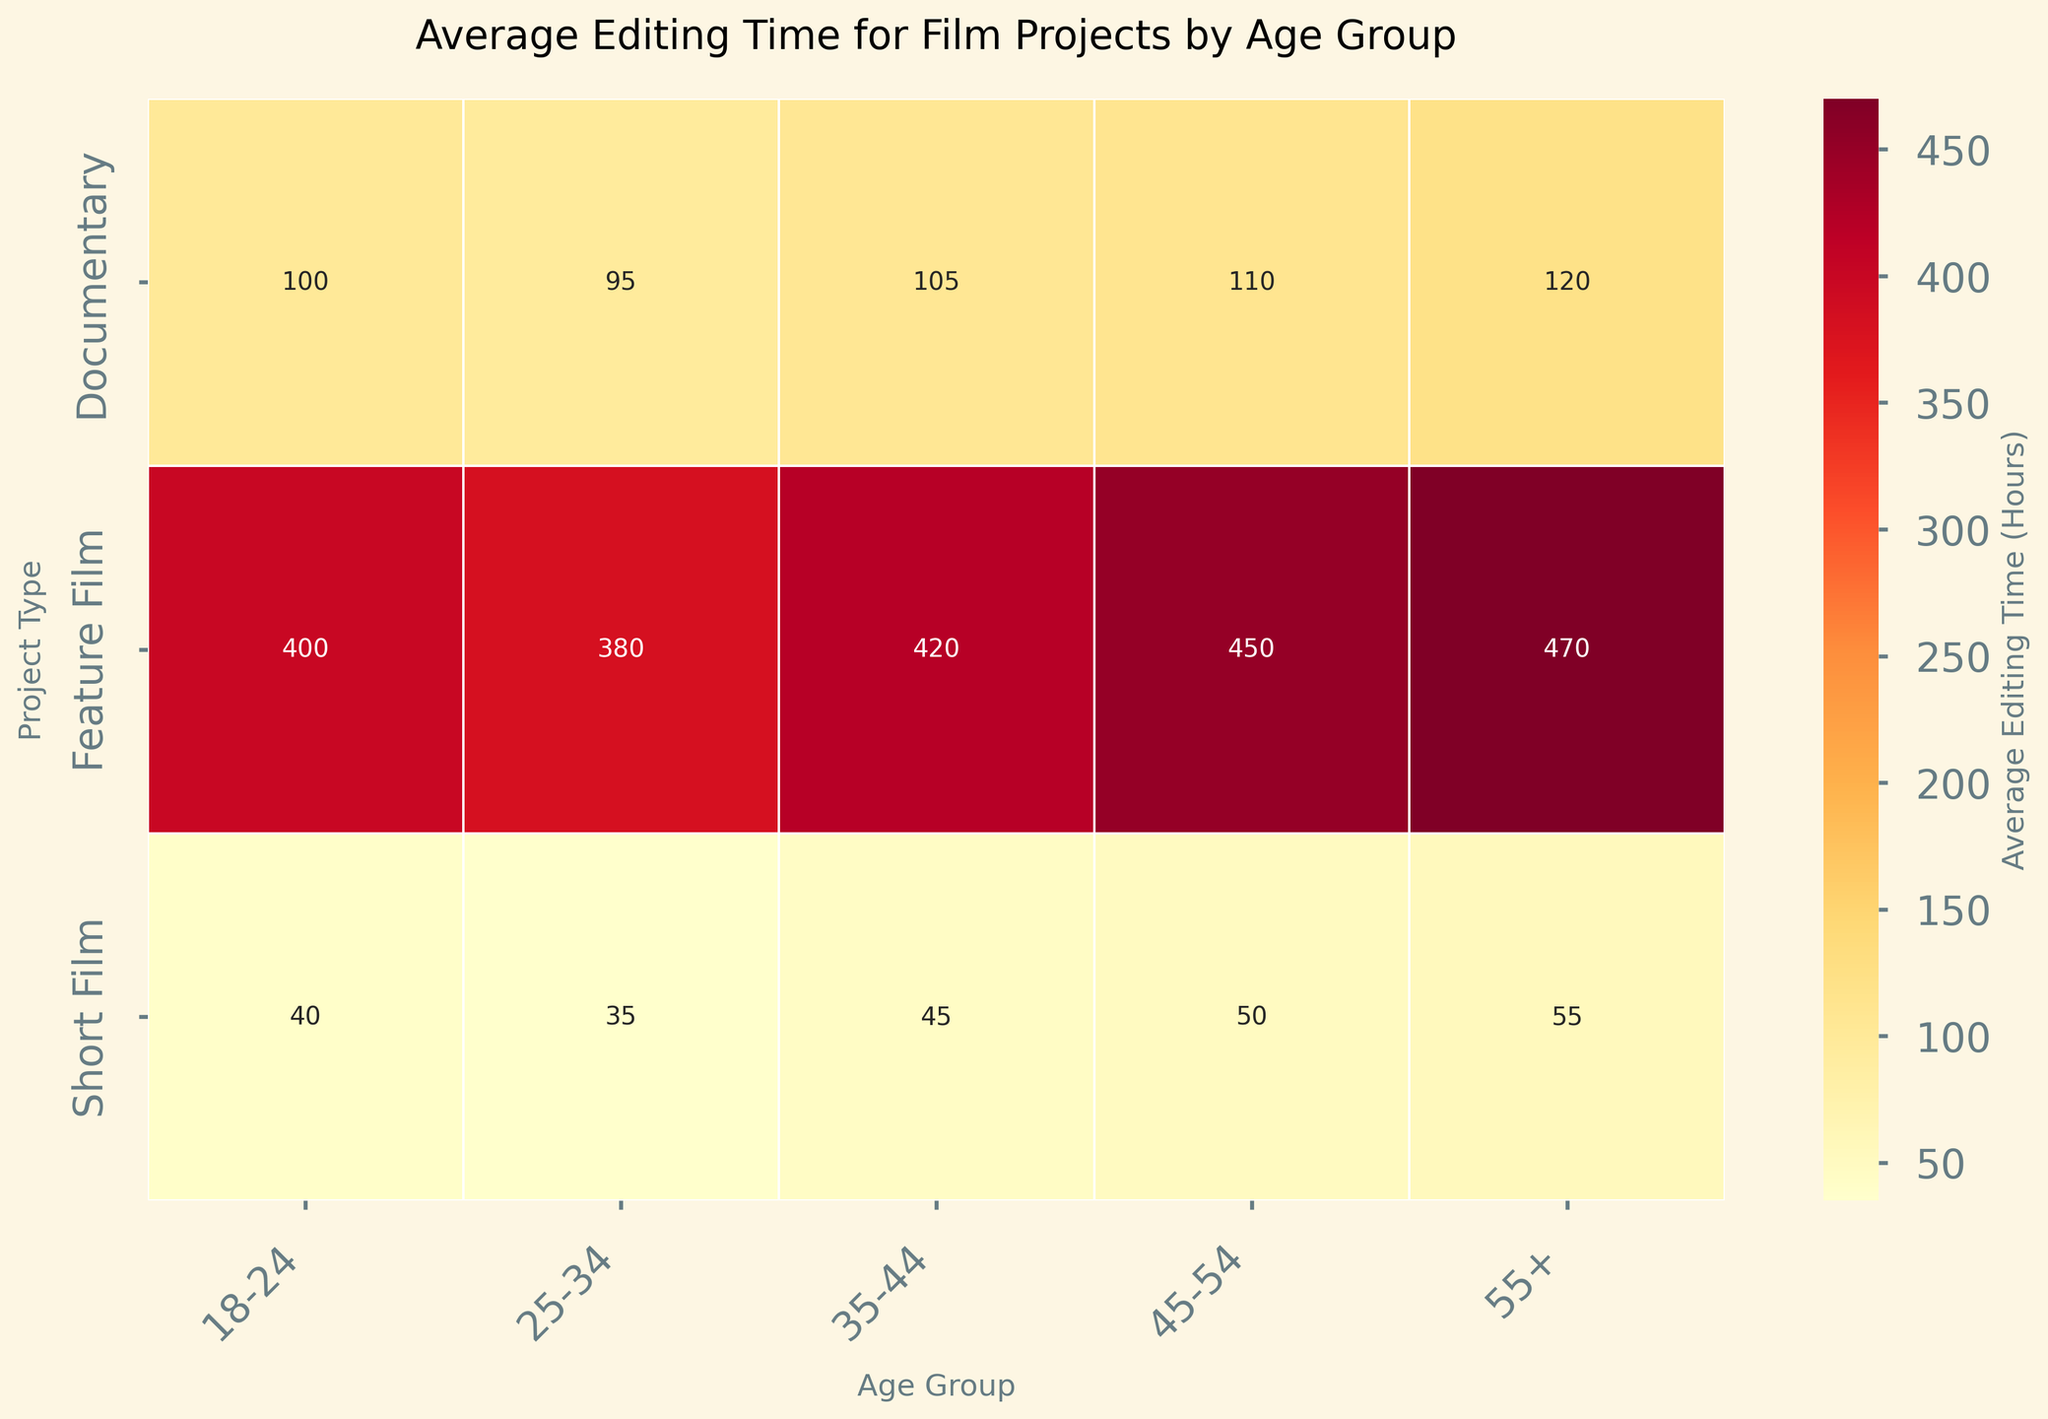what is the title of the plot? The title is usually at the top of the plot in a larger font size for easy identification.
Answer: Average Editing Time for Film Projects by Age Group What are the age groups listed on the x-axis? Check the labels on the x-axis where different age groups are listed.
Answer: 18-24, 25-34, 35-44, 45-54, 55+ How does the average editing time for documentaries change across age groups? Look at the row labeled "Documentary" and compare the values across the age groups.
Answer: Increases from 100 to 120 hours Which project type has the highest average editing time for the 25-34 age group? Compare the values under the "25-34" column for all project types and identify the highest one.
Answer: Feature Film What is the combined average editing time for short films and documentaries in the 45-54 age group? Add the values for short films and documentaries in the "45-54" column. 50 (short film) + 110 (documentary) = 160
Answer: 160 hours Which age group spends the most average time editing feature films? Locate the "Feature Film" row and identify the highest value and its corresponding age group.
Answer: 55+ Is the average editing time for 18-24 age group higher for short films or documentaries? Compare the values under the "18-24" column for short films and documentaries.
Answer: Documentaries How much more time, on average, does the 55+ age group spend editing documentaries compared to the 18-24 age group? Calculate the difference between the values for the 55+ and 18-24 age groups under documentaries. 120 - 100 = 20
Answer: 20 hours Which type of film project shows the least variation in average editing time across all age groups? Compare the range of values (maximum minus minimum) across the rows. Short Film: 55 - 35 = 20, Documentary: 120 - 95 = 25, Feature Film: 470 - 380 = 90. Short films have the least variation.
Answer: Short Films What can you say about the trend of average editing time for feature films as age increases? Observe the values in the "Feature Film" row, noting how they change from the youngest to the oldest age group.
Answer: Increases 